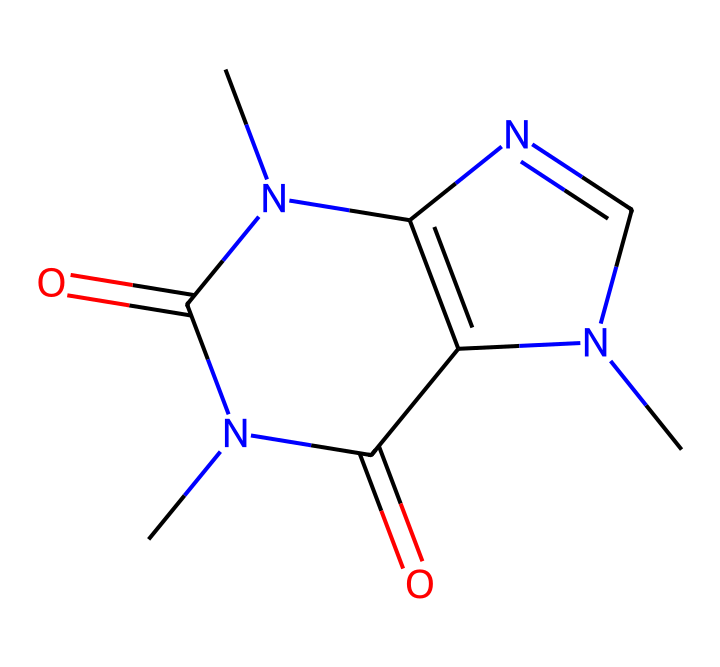how many carbon atoms are in the caffeine structure? By examining the chemical structure, we can count the carbon atoms present. Each vertex and end that does not have a functional group represents a carbon atom; additionally, some carbons may be indicated as part of rings. The molecule has six carbon atoms in total.
Answer: six what is the total number of nitrogen atoms in the caffeine molecule? In the provided structure, nitrogen atoms are typically shown as N. Counting these, we find four distinct nitrogen atoms present in the caffeine structure.
Answer: four does caffeine contain any double bonds? By looking at the connections between the atoms, we identify any multiple bonds. In this case, we see that there are double bonds present, as indicated by the "=" symbol between certain atoms.
Answer: yes what functional groups are present in caffeine? To determine the functional groups, we need to identify the specific arrangements of atoms that characterize functional groups such as amides or amines. In this structure, we see amide functional groups due to the presence of -C(=O)N- units.
Answer: amide what type of molecule is caffeine classified as? Based on its structure, caffeine is classified based on its cyclic and nitrogen-containing features. This categorization reveals that caffeine is classified as an alkaloid, which includes compounds that are derived from plants and often have psychoactive properties.
Answer: alkaloid how many rings are present in the caffeine structure? To find the number of rings, we need to look for any closed loops in the molecular structure. Caffeine has a fused bicyclic structure, which includes two interconnected rings, thus making a total of two rings.
Answer: two what is the molecular formula for caffeine? By aggregating the number of each type of atom identified from the chemical structure (6 carbon, 8 hydrogen, 4 nitrogen, and 2 oxygen), the molecular formula can be constructed as C8H10N4O2.
Answer: C8H10N4O2 